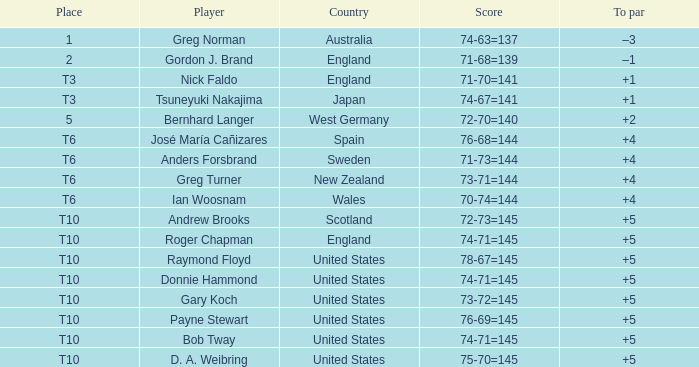What is Greg Norman's place? 1.0. 